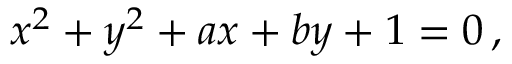<formula> <loc_0><loc_0><loc_500><loc_500>x ^ { 2 } + y ^ { 2 } + a x + b y + 1 = 0 \, ,</formula> 